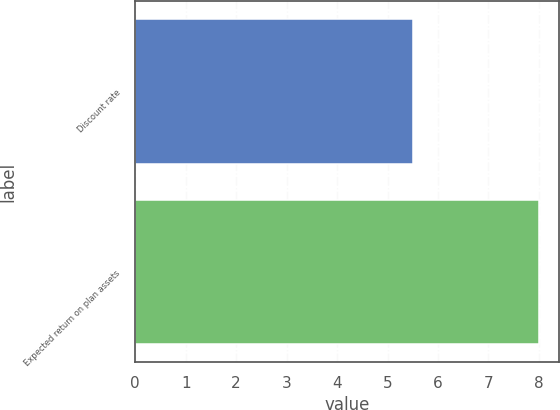<chart> <loc_0><loc_0><loc_500><loc_500><bar_chart><fcel>Discount rate<fcel>Expected return on plan assets<nl><fcel>5.5<fcel>8<nl></chart> 